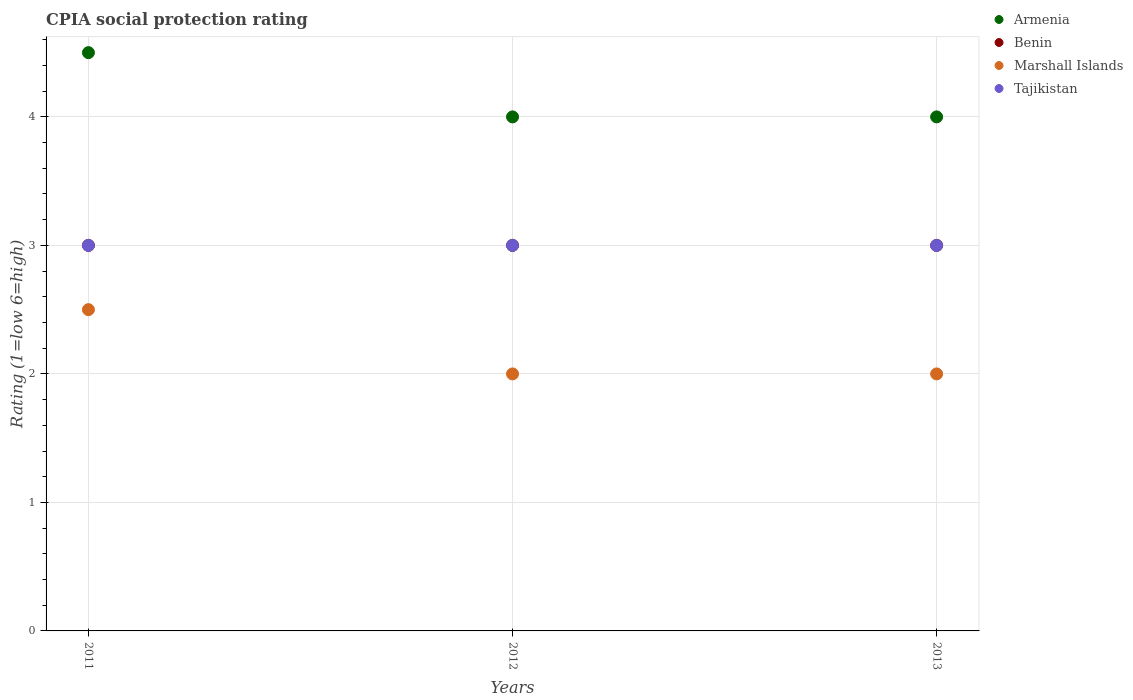How many different coloured dotlines are there?
Give a very brief answer. 4. In which year was the CPIA rating in Benin minimum?
Your answer should be compact. 2011. What is the difference between the CPIA rating in Benin in 2011 and the CPIA rating in Armenia in 2013?
Offer a very short reply. -1. What is the average CPIA rating in Armenia per year?
Your answer should be compact. 4.17. In how many years, is the CPIA rating in Tajikistan greater than 1.6?
Your response must be concise. 3. Is the difference between the CPIA rating in Armenia in 2011 and 2012 greater than the difference between the CPIA rating in Benin in 2011 and 2012?
Offer a terse response. Yes. What is the difference between the highest and the second highest CPIA rating in Marshall Islands?
Ensure brevity in your answer.  0.5. Is it the case that in every year, the sum of the CPIA rating in Marshall Islands and CPIA rating in Tajikistan  is greater than the CPIA rating in Armenia?
Provide a short and direct response. Yes. Does the CPIA rating in Armenia monotonically increase over the years?
Give a very brief answer. No. Is the CPIA rating in Tajikistan strictly greater than the CPIA rating in Benin over the years?
Give a very brief answer. No. Is the CPIA rating in Marshall Islands strictly less than the CPIA rating in Armenia over the years?
Your answer should be compact. Yes. How many dotlines are there?
Make the answer very short. 4. How many years are there in the graph?
Provide a short and direct response. 3. What is the difference between two consecutive major ticks on the Y-axis?
Ensure brevity in your answer.  1. Where does the legend appear in the graph?
Provide a short and direct response. Top right. How many legend labels are there?
Your answer should be very brief. 4. How are the legend labels stacked?
Your answer should be compact. Vertical. What is the title of the graph?
Your answer should be compact. CPIA social protection rating. What is the label or title of the X-axis?
Your answer should be compact. Years. What is the label or title of the Y-axis?
Provide a short and direct response. Rating (1=low 6=high). What is the Rating (1=low 6=high) in Marshall Islands in 2011?
Your response must be concise. 2.5. What is the Rating (1=low 6=high) in Tajikistan in 2011?
Your answer should be very brief. 3. What is the Rating (1=low 6=high) of Benin in 2012?
Provide a short and direct response. 3. What is the Rating (1=low 6=high) in Marshall Islands in 2012?
Give a very brief answer. 2. What is the Rating (1=low 6=high) in Marshall Islands in 2013?
Give a very brief answer. 2. Across all years, what is the maximum Rating (1=low 6=high) of Benin?
Your answer should be compact. 3. Across all years, what is the minimum Rating (1=low 6=high) in Marshall Islands?
Your response must be concise. 2. What is the total Rating (1=low 6=high) in Armenia in the graph?
Give a very brief answer. 12.5. What is the total Rating (1=low 6=high) of Benin in the graph?
Your answer should be very brief. 9. What is the difference between the Rating (1=low 6=high) of Benin in 2011 and that in 2012?
Give a very brief answer. 0. What is the difference between the Rating (1=low 6=high) in Benin in 2011 and that in 2013?
Your response must be concise. 0. What is the difference between the Rating (1=low 6=high) of Marshall Islands in 2011 and that in 2013?
Give a very brief answer. 0.5. What is the difference between the Rating (1=low 6=high) of Benin in 2012 and that in 2013?
Provide a short and direct response. 0. What is the difference between the Rating (1=low 6=high) of Armenia in 2011 and the Rating (1=low 6=high) of Benin in 2012?
Provide a short and direct response. 1.5. What is the difference between the Rating (1=low 6=high) in Armenia in 2011 and the Rating (1=low 6=high) in Marshall Islands in 2012?
Provide a short and direct response. 2.5. What is the difference between the Rating (1=low 6=high) in Armenia in 2011 and the Rating (1=low 6=high) in Tajikistan in 2012?
Your answer should be compact. 1.5. What is the difference between the Rating (1=low 6=high) of Benin in 2011 and the Rating (1=low 6=high) of Tajikistan in 2012?
Your answer should be compact. 0. What is the difference between the Rating (1=low 6=high) in Marshall Islands in 2011 and the Rating (1=low 6=high) in Tajikistan in 2012?
Keep it short and to the point. -0.5. What is the difference between the Rating (1=low 6=high) in Armenia in 2011 and the Rating (1=low 6=high) in Tajikistan in 2013?
Give a very brief answer. 1.5. What is the difference between the Rating (1=low 6=high) of Benin in 2011 and the Rating (1=low 6=high) of Tajikistan in 2013?
Provide a succinct answer. 0. What is the difference between the Rating (1=low 6=high) of Marshall Islands in 2011 and the Rating (1=low 6=high) of Tajikistan in 2013?
Ensure brevity in your answer.  -0.5. What is the difference between the Rating (1=low 6=high) of Armenia in 2012 and the Rating (1=low 6=high) of Benin in 2013?
Your answer should be compact. 1. What is the difference between the Rating (1=low 6=high) of Armenia in 2012 and the Rating (1=low 6=high) of Marshall Islands in 2013?
Provide a succinct answer. 2. What is the difference between the Rating (1=low 6=high) in Armenia in 2012 and the Rating (1=low 6=high) in Tajikistan in 2013?
Provide a succinct answer. 1. What is the difference between the Rating (1=low 6=high) in Marshall Islands in 2012 and the Rating (1=low 6=high) in Tajikistan in 2013?
Your response must be concise. -1. What is the average Rating (1=low 6=high) of Armenia per year?
Provide a succinct answer. 4.17. What is the average Rating (1=low 6=high) in Benin per year?
Offer a very short reply. 3. What is the average Rating (1=low 6=high) of Marshall Islands per year?
Your answer should be compact. 2.17. What is the average Rating (1=low 6=high) in Tajikistan per year?
Provide a succinct answer. 3. In the year 2011, what is the difference between the Rating (1=low 6=high) in Armenia and Rating (1=low 6=high) in Tajikistan?
Make the answer very short. 1.5. In the year 2011, what is the difference between the Rating (1=low 6=high) of Benin and Rating (1=low 6=high) of Tajikistan?
Offer a very short reply. 0. In the year 2011, what is the difference between the Rating (1=low 6=high) in Marshall Islands and Rating (1=low 6=high) in Tajikistan?
Offer a very short reply. -0.5. In the year 2012, what is the difference between the Rating (1=low 6=high) in Benin and Rating (1=low 6=high) in Marshall Islands?
Your answer should be very brief. 1. In the year 2012, what is the difference between the Rating (1=low 6=high) in Marshall Islands and Rating (1=low 6=high) in Tajikistan?
Provide a succinct answer. -1. In the year 2013, what is the difference between the Rating (1=low 6=high) in Armenia and Rating (1=low 6=high) in Benin?
Your answer should be compact. 1. In the year 2013, what is the difference between the Rating (1=low 6=high) in Armenia and Rating (1=low 6=high) in Marshall Islands?
Offer a terse response. 2. In the year 2013, what is the difference between the Rating (1=low 6=high) of Armenia and Rating (1=low 6=high) of Tajikistan?
Your response must be concise. 1. In the year 2013, what is the difference between the Rating (1=low 6=high) in Benin and Rating (1=low 6=high) in Marshall Islands?
Provide a short and direct response. 1. In the year 2013, what is the difference between the Rating (1=low 6=high) of Benin and Rating (1=low 6=high) of Tajikistan?
Provide a short and direct response. 0. In the year 2013, what is the difference between the Rating (1=low 6=high) of Marshall Islands and Rating (1=low 6=high) of Tajikistan?
Your response must be concise. -1. What is the ratio of the Rating (1=low 6=high) of Armenia in 2011 to that in 2012?
Offer a terse response. 1.12. What is the ratio of the Rating (1=low 6=high) in Marshall Islands in 2011 to that in 2012?
Provide a succinct answer. 1.25. What is the ratio of the Rating (1=low 6=high) in Tajikistan in 2011 to that in 2012?
Give a very brief answer. 1. What is the ratio of the Rating (1=low 6=high) of Benin in 2011 to that in 2013?
Give a very brief answer. 1. What is the ratio of the Rating (1=low 6=high) in Marshall Islands in 2011 to that in 2013?
Your response must be concise. 1.25. What is the ratio of the Rating (1=low 6=high) of Marshall Islands in 2012 to that in 2013?
Keep it short and to the point. 1. What is the ratio of the Rating (1=low 6=high) in Tajikistan in 2012 to that in 2013?
Your response must be concise. 1. What is the difference between the highest and the second highest Rating (1=low 6=high) in Armenia?
Make the answer very short. 0.5. What is the difference between the highest and the second highest Rating (1=low 6=high) in Tajikistan?
Offer a very short reply. 0. What is the difference between the highest and the lowest Rating (1=low 6=high) in Benin?
Keep it short and to the point. 0. What is the difference between the highest and the lowest Rating (1=low 6=high) of Marshall Islands?
Offer a terse response. 0.5. What is the difference between the highest and the lowest Rating (1=low 6=high) of Tajikistan?
Offer a terse response. 0. 